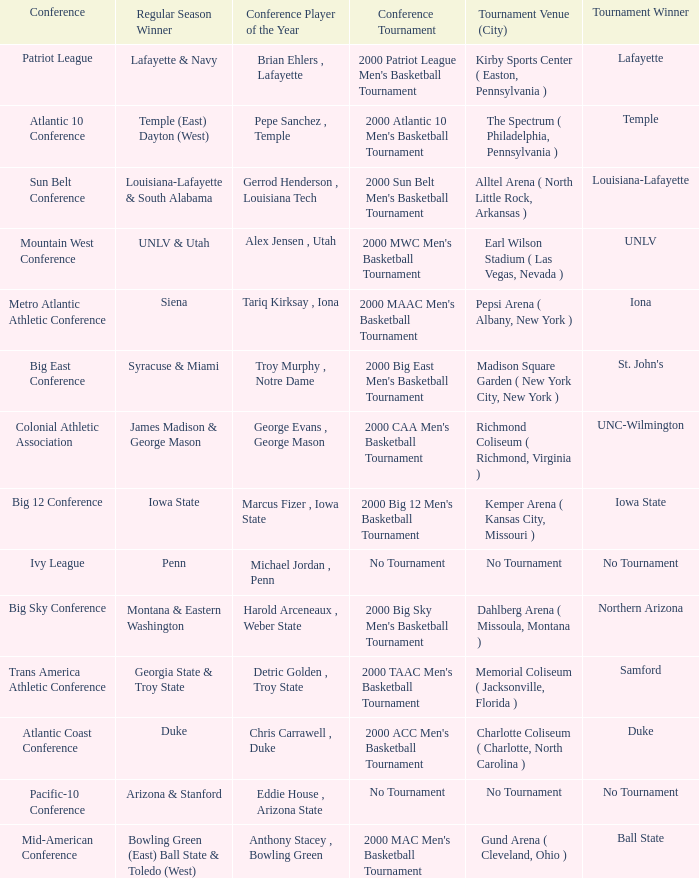Who is the conference Player of the Year in the conference where Lafayette won the tournament? Brian Ehlers , Lafayette. 